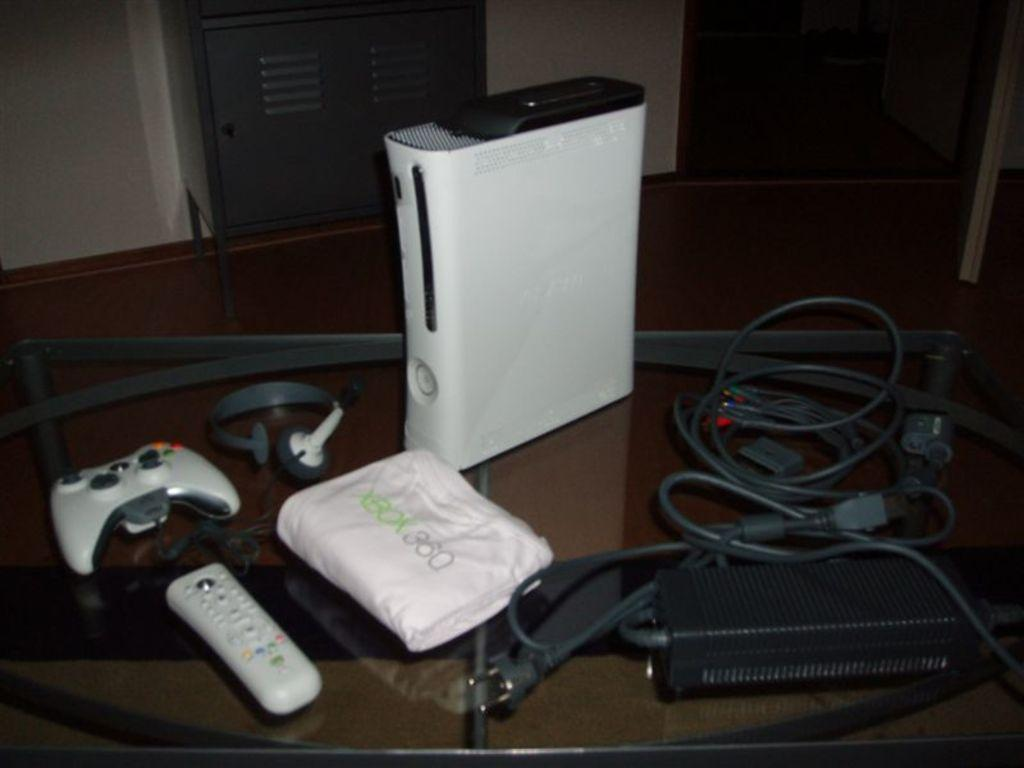<image>
Offer a succinct explanation of the picture presented. On a glass table sits a complete XBOX 360 gaming system. 